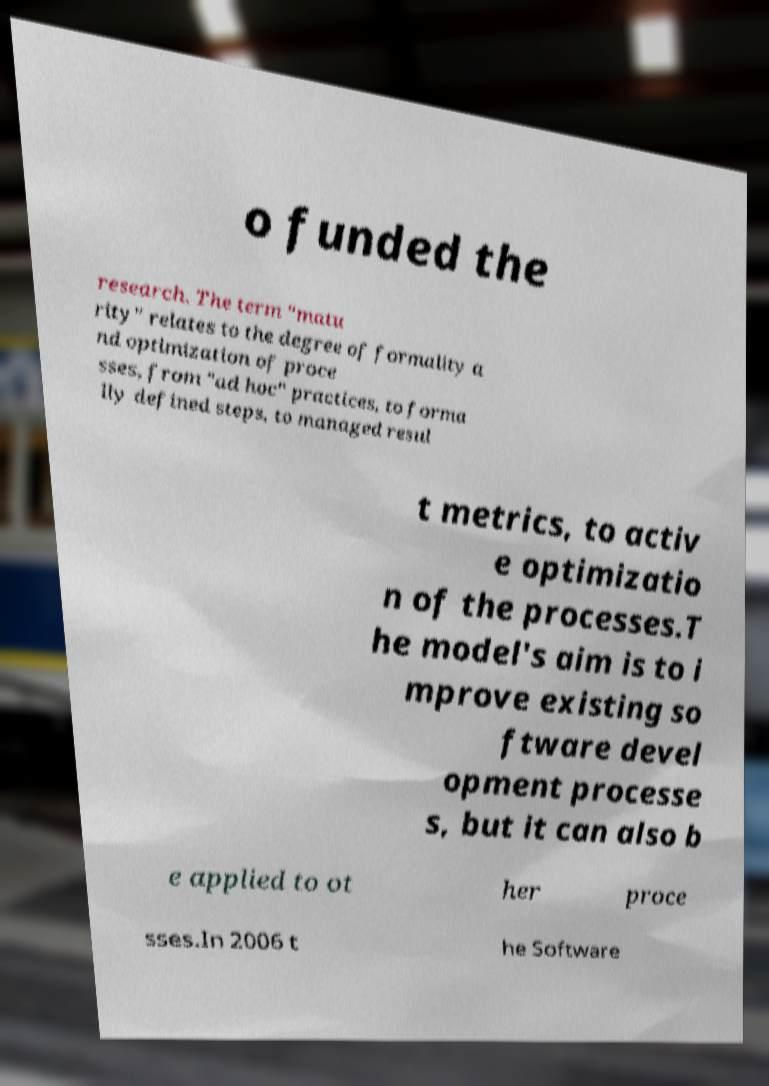I need the written content from this picture converted into text. Can you do that? o funded the research. The term "matu rity" relates to the degree of formality a nd optimization of proce sses, from "ad hoc" practices, to forma lly defined steps, to managed resul t metrics, to activ e optimizatio n of the processes.T he model's aim is to i mprove existing so ftware devel opment processe s, but it can also b e applied to ot her proce sses.In 2006 t he Software 